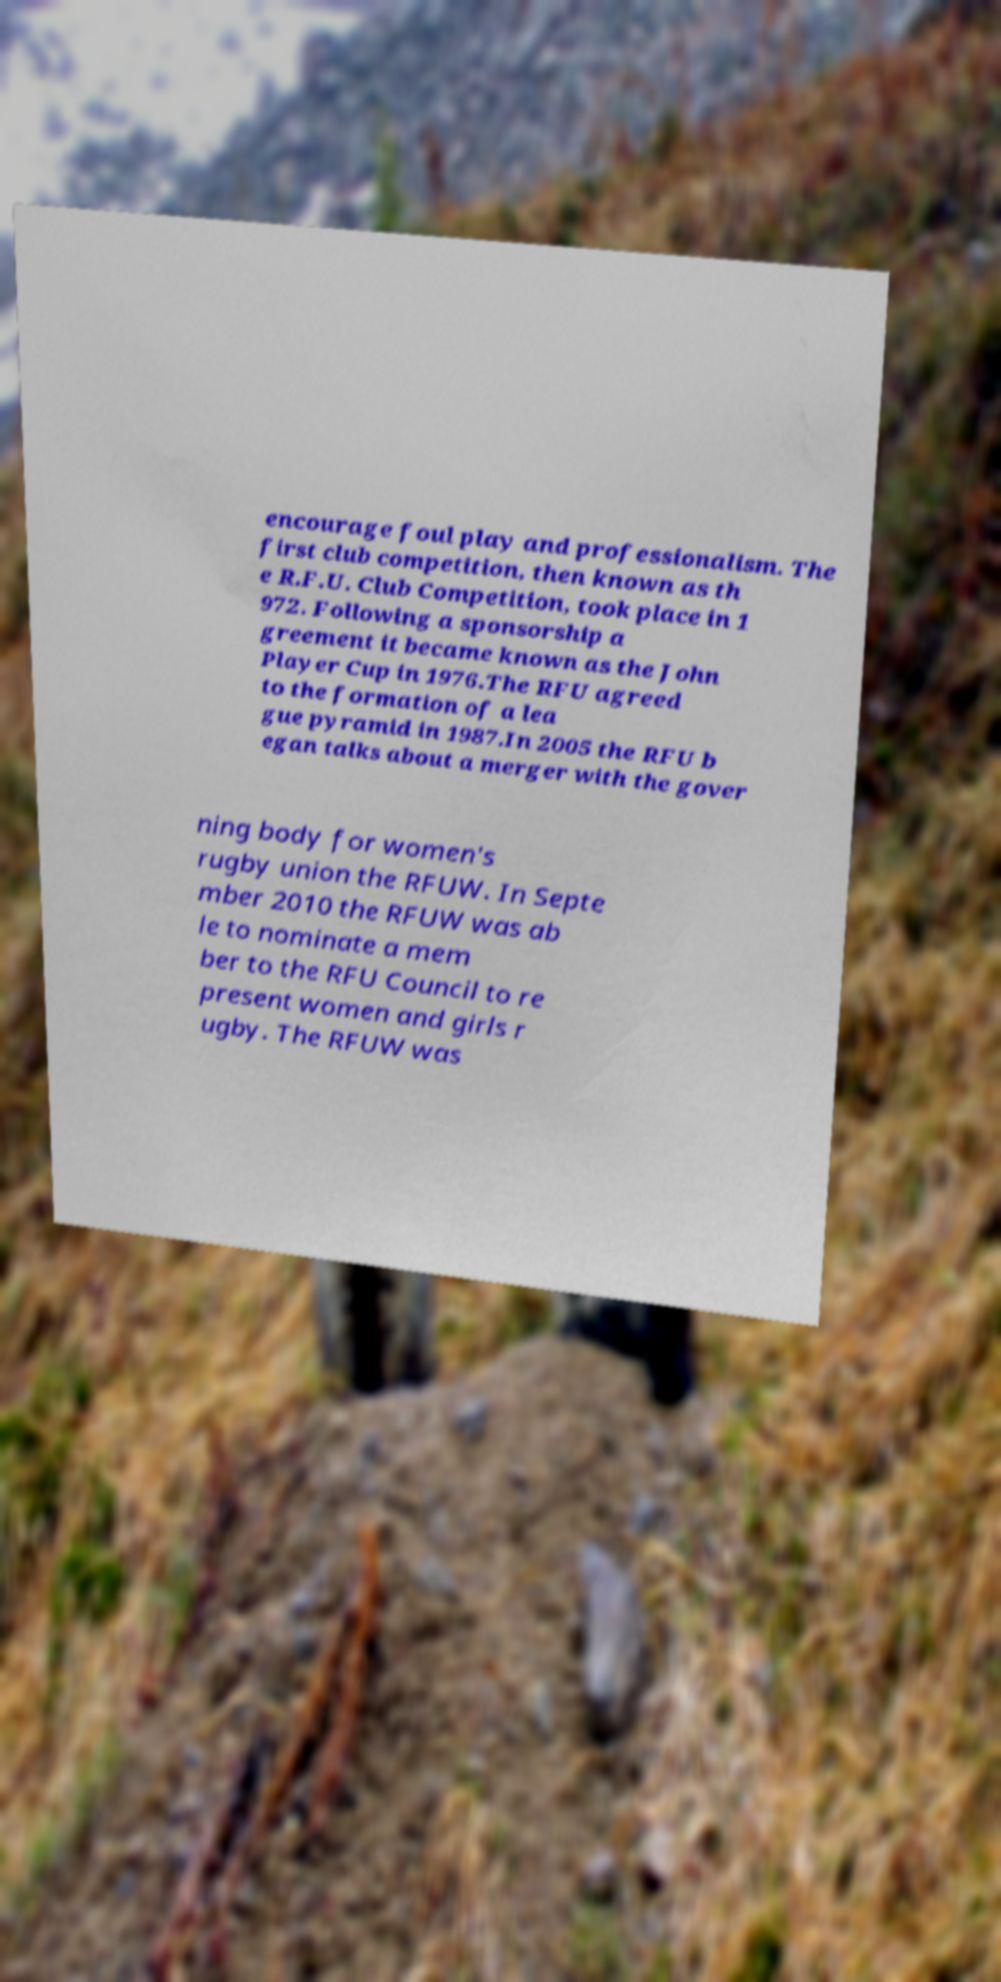Please identify and transcribe the text found in this image. encourage foul play and professionalism. The first club competition, then known as th e R.F.U. Club Competition, took place in 1 972. Following a sponsorship a greement it became known as the John Player Cup in 1976.The RFU agreed to the formation of a lea gue pyramid in 1987.In 2005 the RFU b egan talks about a merger with the gover ning body for women's rugby union the RFUW. In Septe mber 2010 the RFUW was ab le to nominate a mem ber to the RFU Council to re present women and girls r ugby. The RFUW was 